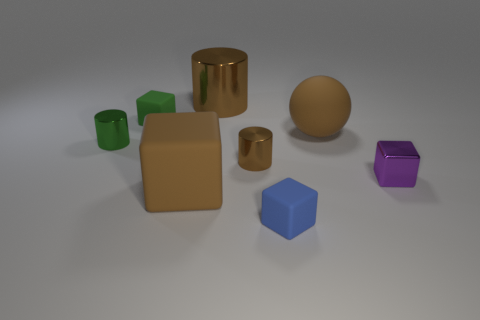Subtract 1 blocks. How many blocks are left? 3 Add 1 small metal cylinders. How many objects exist? 9 Subtract all cylinders. How many objects are left? 5 Add 7 small cubes. How many small cubes are left? 10 Add 4 big matte cubes. How many big matte cubes exist? 5 Subtract 0 red cylinders. How many objects are left? 8 Subtract all big brown metallic things. Subtract all blue rubber things. How many objects are left? 6 